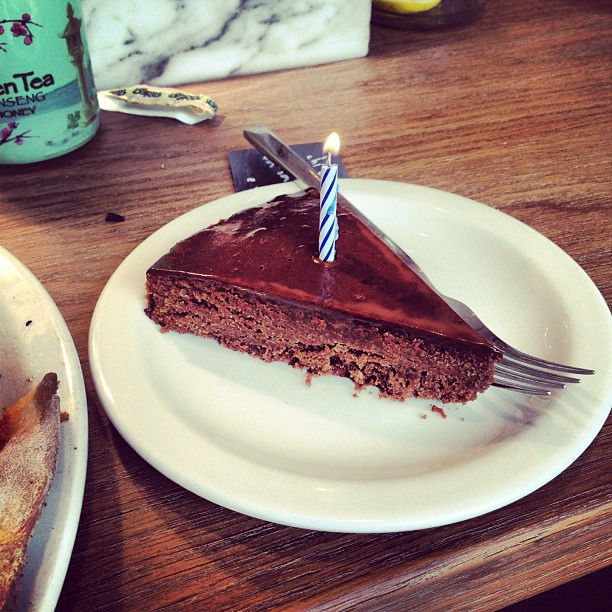Identify the text displayed in this image. Tea NSENG ONEY N 